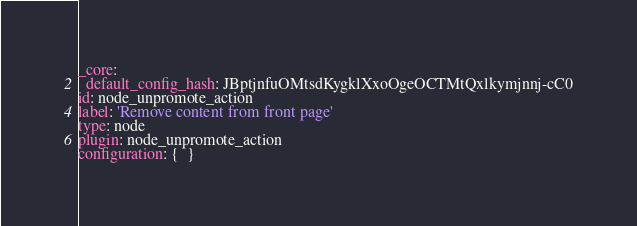Convert code to text. <code><loc_0><loc_0><loc_500><loc_500><_YAML_>_core:
  default_config_hash: JBptjnfuOMtsdKygklXxoOgeOCTMtQxlkymjnnj-cC0
id: node_unpromote_action
label: 'Remove content from front page'
type: node
plugin: node_unpromote_action
configuration: {  }
</code> 